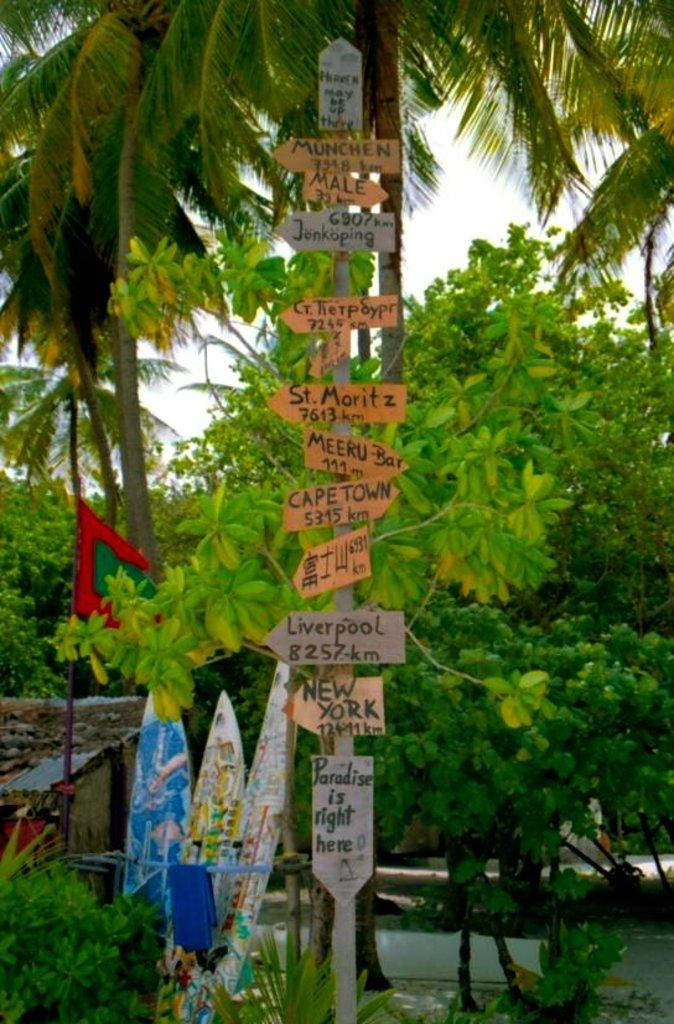What is attached to the pole in the image? There are sign boards on a pole in the image. What can be seen behind the sign boards? There are surfing boards behind the sign boards. What type of vegetation is present in the image? There are plants and trees in the image. What type of structure is visible in the image? There is a house in the image. What type of nation is represented by the sign boards in the image? The image does not provide information about the nation represented by the sign boards. Where is the playground located in the image? There is no playground present in the image. 